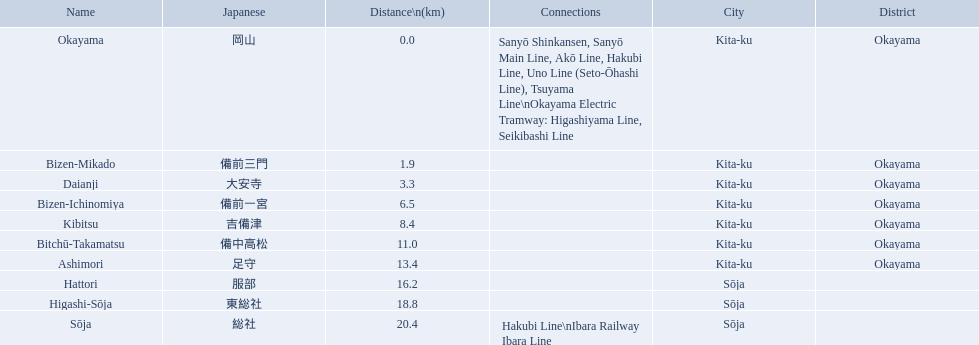What are all the stations on the kibi line? Okayama, Bizen-Mikado, Daianji, Bizen-Ichinomiya, Kibitsu, Bitchū-Takamatsu, Ashimori, Hattori, Higashi-Sōja, Sōja. What are the distances of these stations from the start of the line? 0.0, 1.9, 3.3, 6.5, 8.4, 11.0, 13.4, 16.2, 18.8, 20.4. Of these, which is larger than 1 km? 1.9, 3.3, 6.5, 8.4, 11.0, 13.4, 16.2, 18.8, 20.4. Of these, which is smaller than 2 km? 1.9. Which station is this distance from the start of the line? Bizen-Mikado. 